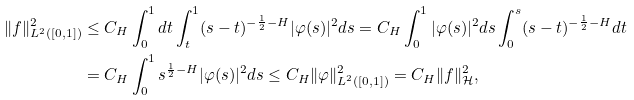Convert formula to latex. <formula><loc_0><loc_0><loc_500><loc_500>\| f \| _ { L ^ { 2 } ( [ 0 , 1 ] ) } ^ { 2 } & \leq C _ { H } \int _ { 0 } ^ { 1 } d t \int _ { t } ^ { 1 } ( s - t ) ^ { - \frac { 1 } { 2 } - H } | \varphi ( s ) | ^ { 2 } d s = C _ { H } \int _ { 0 } ^ { 1 } | \varphi ( s ) | ^ { 2 } d s \int _ { 0 } ^ { s } ( s - t ) ^ { - \frac { 1 } { 2 } - H } d t \\ & = C _ { H } \int _ { 0 } ^ { 1 } s ^ { \frac { 1 } { 2 } - H } | \varphi ( s ) | ^ { 2 } d s \leq C _ { H } \| \varphi \| _ { L ^ { 2 } ( [ 0 , 1 ] ) } ^ { 2 } = C _ { H } \| f \| _ { \mathcal { H } } ^ { 2 } ,</formula> 